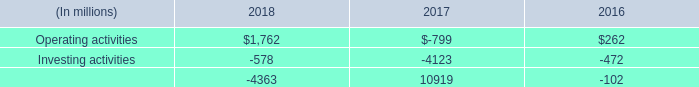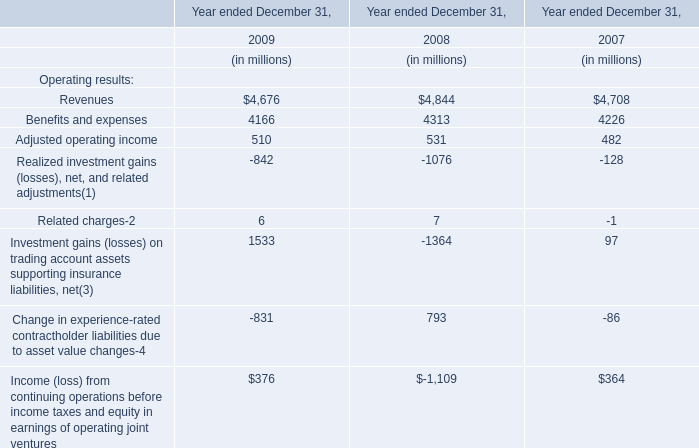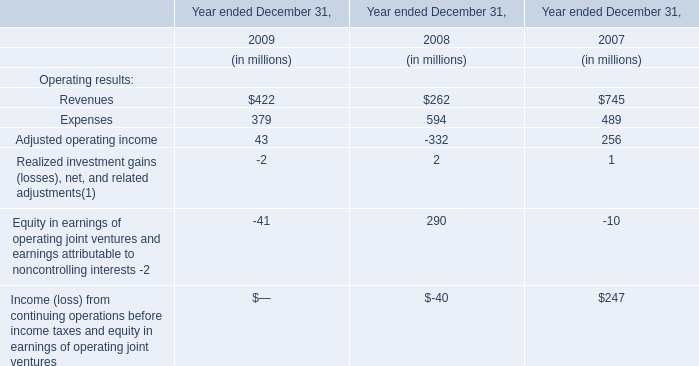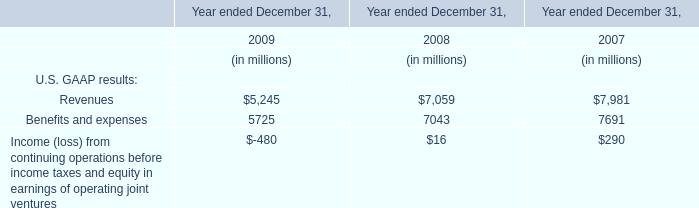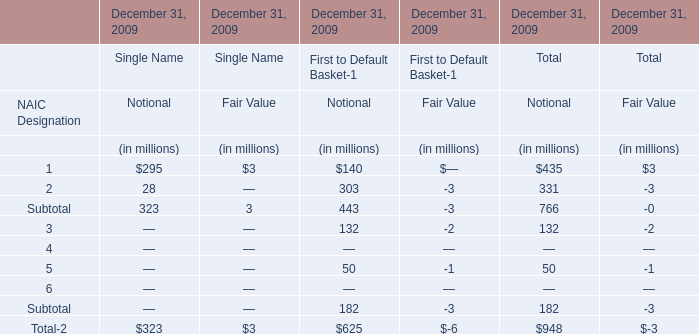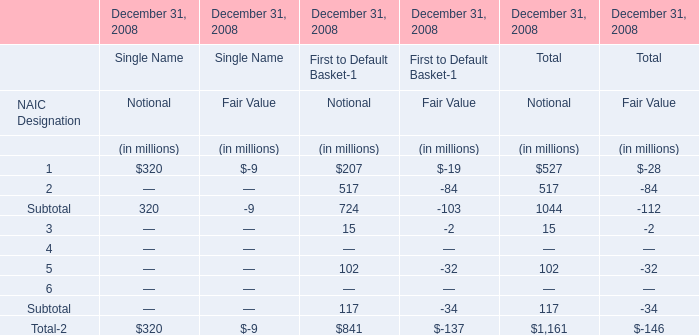What's the greatest value of Subtotal in Single Name (in million) 
Computations: (320 - 9)
Answer: 311.0. 